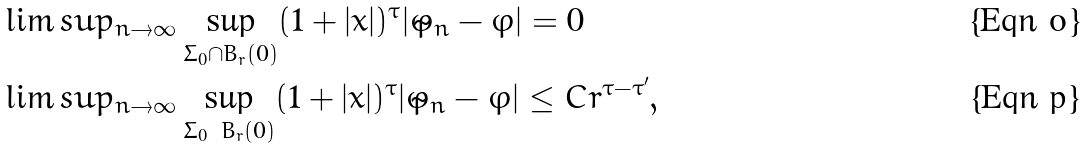<formula> <loc_0><loc_0><loc_500><loc_500>& \lim s u p _ { n \to \infty } \sup _ { \Sigma _ { 0 } \cap B _ { r } ( 0 ) } ( 1 + | x | ) ^ { \tau } | \tilde { \varphi } _ { n } - \varphi | = 0 \\ & \lim s u p _ { n \to \infty } \sup _ { \Sigma _ { 0 } \ B _ { r } ( 0 ) } ( 1 + | x | ) ^ { \tau } | \tilde { \varphi } _ { n } - \varphi | \leq C r ^ { \tau - \tau ^ { \prime } } ,</formula> 